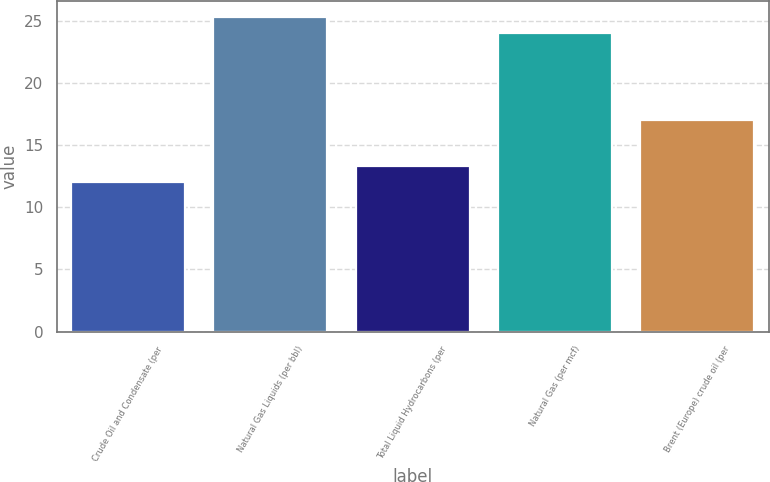Convert chart. <chart><loc_0><loc_0><loc_500><loc_500><bar_chart><fcel>Crude Oil and Condensate (per<fcel>Natural Gas Liquids (per bbl)<fcel>Total Liquid Hydrocarbons (per<fcel>Natural Gas (per mcf)<fcel>Brent (Europe) crude oil (per<nl><fcel>12<fcel>25.3<fcel>13.3<fcel>24<fcel>17<nl></chart> 